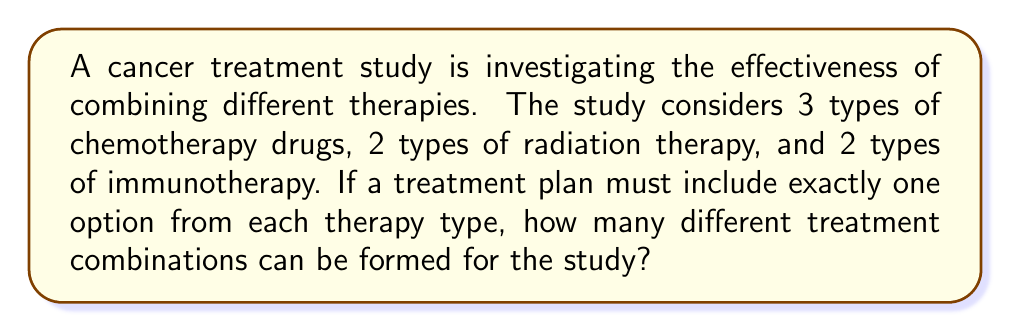Solve this math problem. To solve this problem, we'll use the multiplication principle of counting. This principle states that if we have a sequence of independent choices, the total number of possible outcomes is the product of the number of possibilities for each choice.

Let's break down the problem:

1. Chemotherapy drugs: 3 options
2. Radiation therapy: 2 options
3. Immunotherapy: 2 options

For each treatment combination, we must choose:
- One option from the chemotherapy drugs (3 choices)
- One option from the radiation therapy (2 choices)
- One option from the immunotherapy (2 choices)

These choices are independent of each other, meaning the selection of one does not affect the options available for the others.

Therefore, we can apply the multiplication principle:

$$ \text{Total combinations} = 3 \times 2 \times 2 $$

Calculating this:

$$ \text{Total combinations} = 3 \times 2 \times 2 = 12 $$

This means there are 12 possible unique treatment combinations that can be formed for the study.
Answer: 12 treatment combinations 